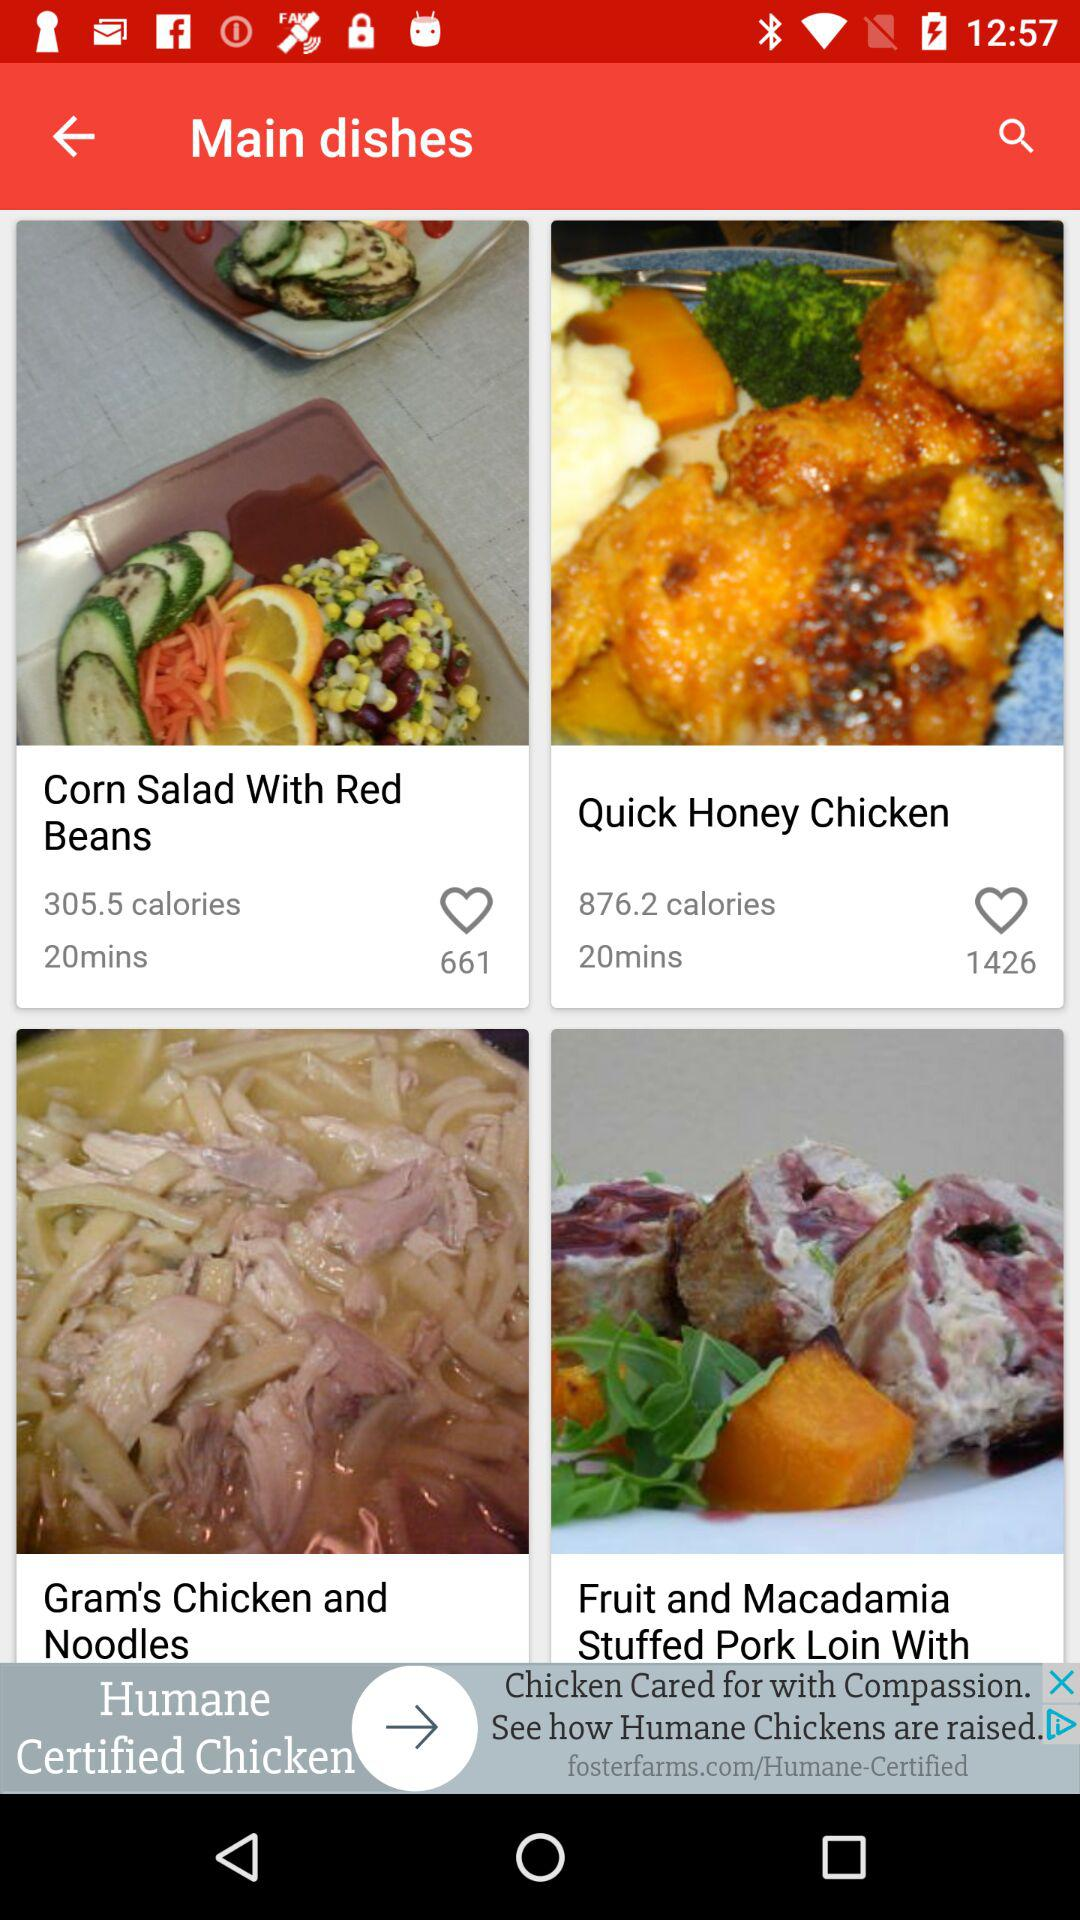How many likes are there on "Quick Honey Chicken"? There are 1426 likes on "Quick Honey Chicken". 